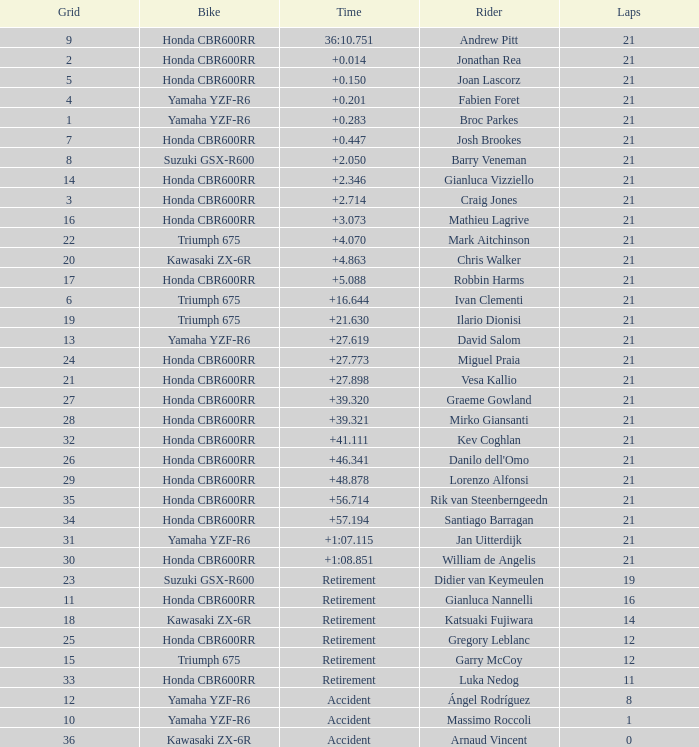What driver had the highest grid position with a time of +0.283? 1.0. 